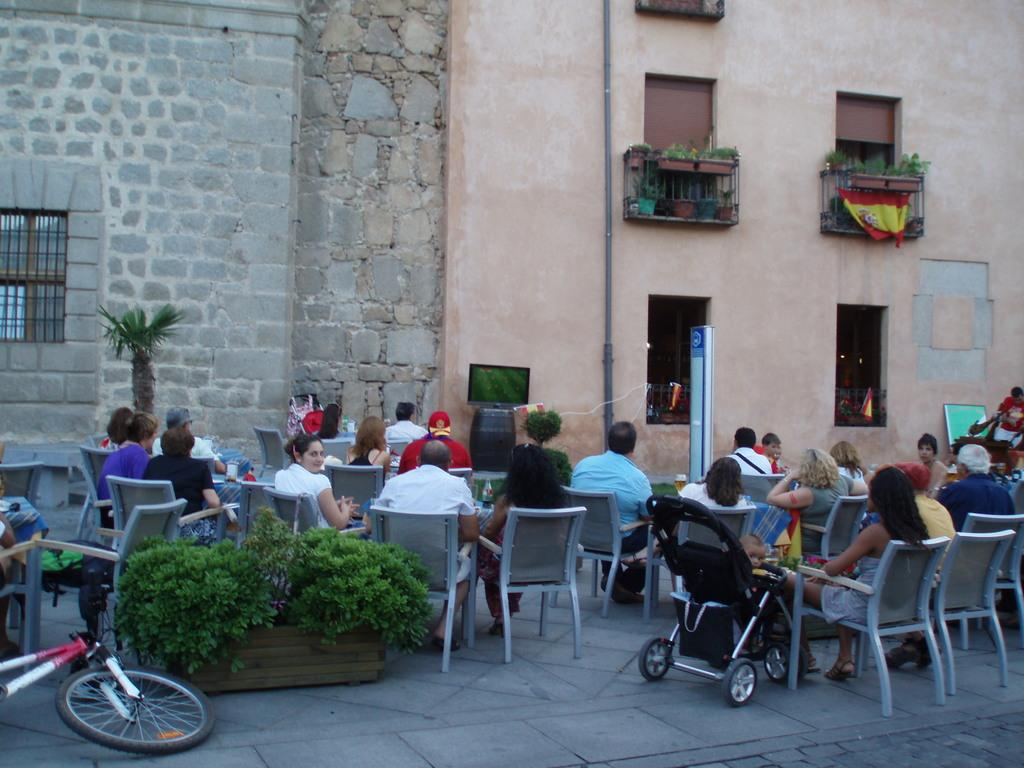What are the people in the image doing? There is a group of people sitting on chairs in the image. What object can be seen on the floor? There is a bicycle on the floor in the image. What type of plant container is present in the image? There is a flower pot in the image. What type of structure is visible in the background? There is a building in the image. What type of bat is flying around the people in the image? There is no bat present in the image; it only features a group of people sitting on chairs, a bicycle on the floor, a flower pot, and a building in the background. 